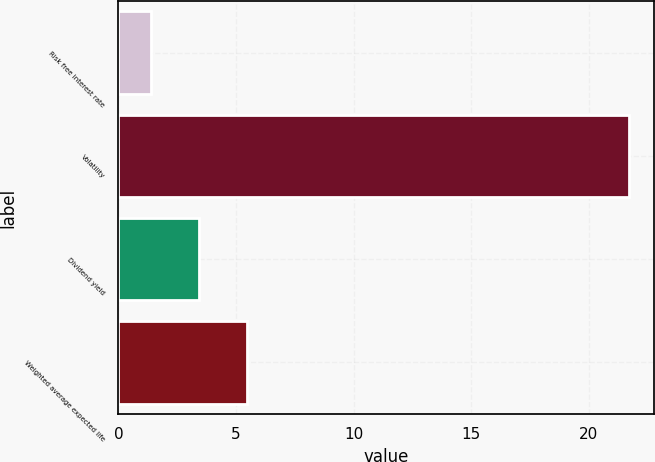<chart> <loc_0><loc_0><loc_500><loc_500><bar_chart><fcel>Risk free interest rate<fcel>Volatility<fcel>Dividend yield<fcel>Weighted average expected life<nl><fcel>1.4<fcel>21.7<fcel>3.43<fcel>5.46<nl></chart> 